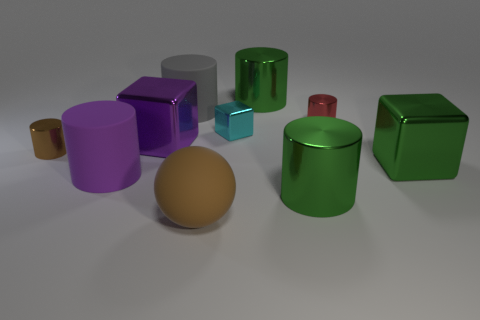Subtract all green metal blocks. How many blocks are left? 2 Subtract 1 cubes. How many cubes are left? 2 Subtract all purple blocks. How many green cylinders are left? 2 Subtract all green cubes. How many cubes are left? 2 Subtract 0 red spheres. How many objects are left? 10 Subtract all cubes. How many objects are left? 7 Subtract all yellow blocks. Subtract all red spheres. How many blocks are left? 3 Subtract all big matte objects. Subtract all cubes. How many objects are left? 4 Add 9 small brown objects. How many small brown objects are left? 10 Add 2 matte objects. How many matte objects exist? 5 